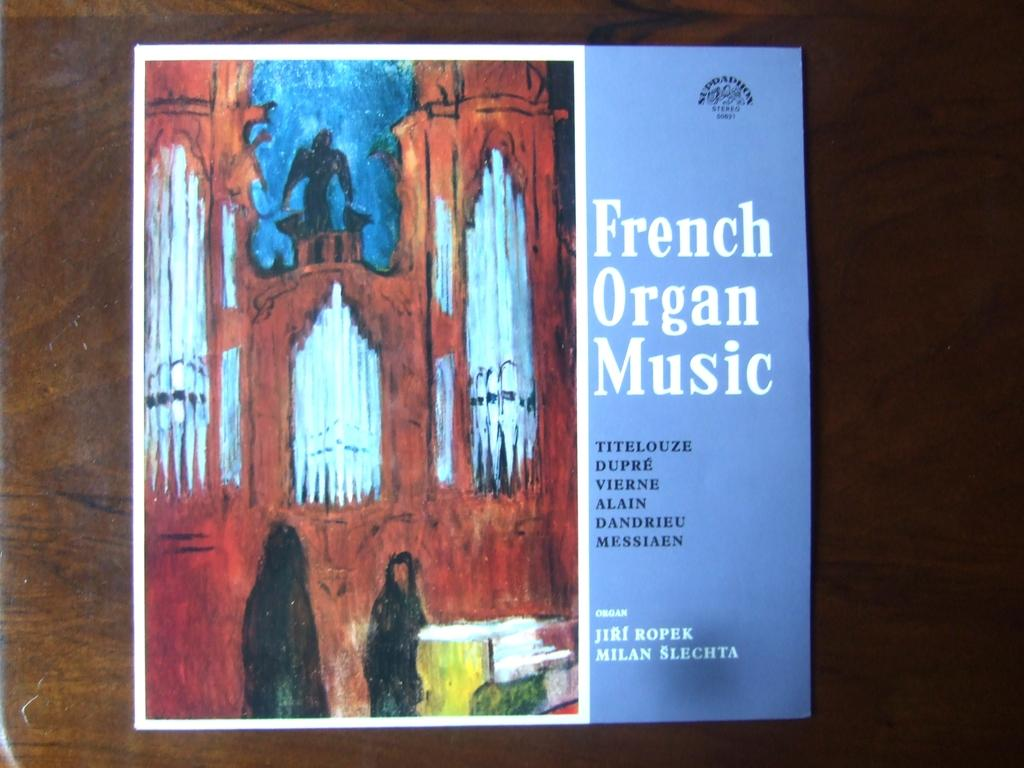<image>
Create a compact narrative representing the image presented. a book with the name of French organ music 